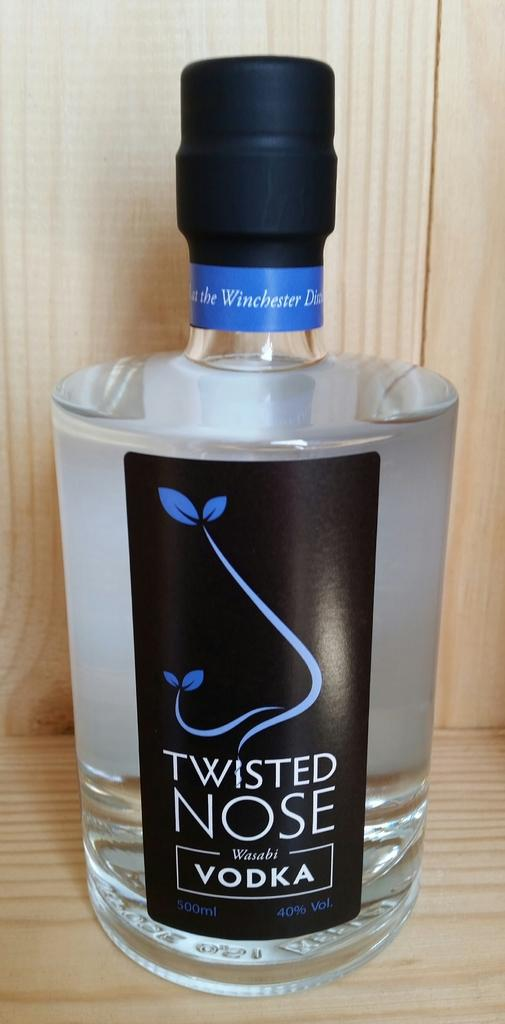<image>
Relay a brief, clear account of the picture shown. On the counter sits a full, large bottle of Twisted Nose vodka. 